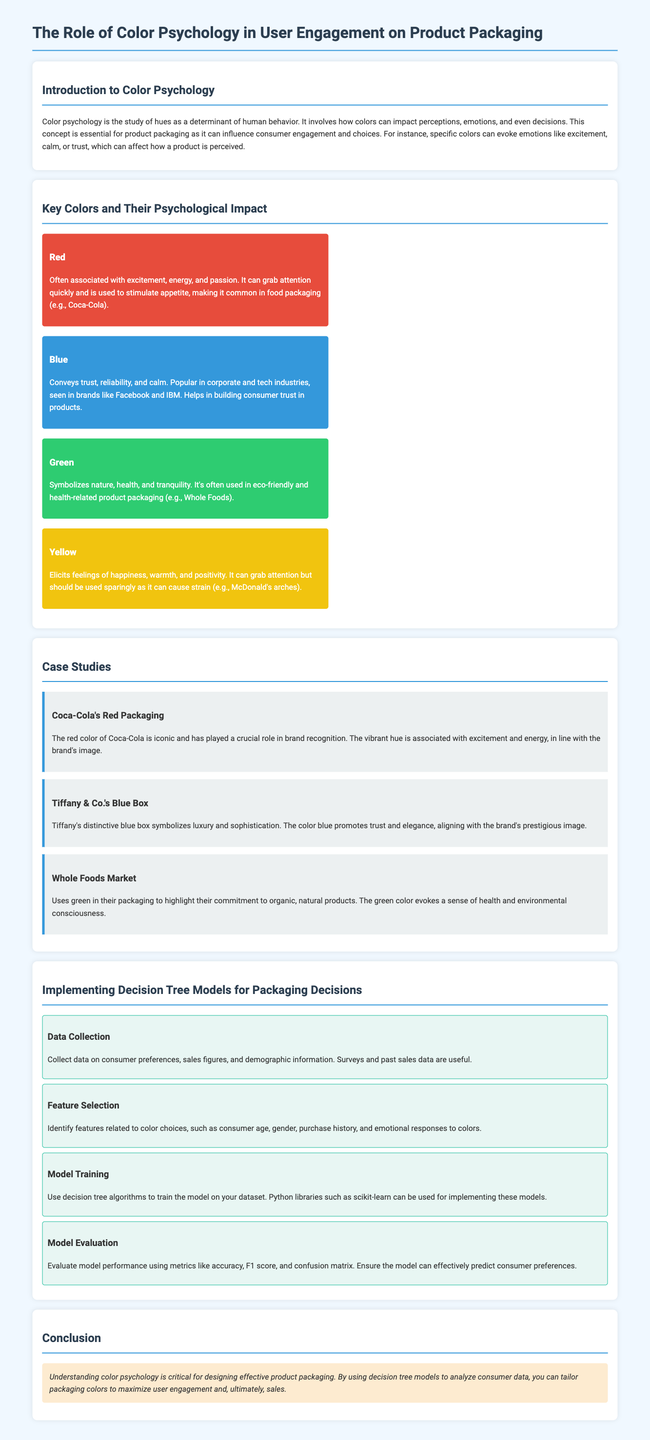What does color psychology study? Color psychology studies hues as determinants of human behavior, impacting perceptions, emotions, and decisions.
Answer: Hues What color is associated with trust? The document states that blue conveys trust, reliability, and calm.
Answer: Blue Which company utilizes red in its packaging? The case study mentions Coca-Cola's use of red packaging, which is iconic for the brand.
Answer: Coca-Cola What are two features to identify related to color choices? The document suggests consumer age and gender, as well as purchase history and emotional responses to colors.
Answer: Age and gender Which color represents nature and health? The psychological impact section indicates that green symbolizes nature, health, and tranquility.
Answer: Green What is one method for model evaluation mentioned? The document outlines the use of metrics like accuracy, F1 score, and confusion matrix to evaluate model performance.
Answer: Accuracy What does Whole Foods Market highlight in their packaging? Whole Foods Market uses green to highlight their commitment to organic, natural products.
Answer: Organic What is the main purpose of using decision tree models in packaging decisions? The conclusion states that the main purpose is to analyze consumer data to tailor packaging colors for maximizing user engagement.
Answer: User engagement 